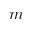<formula> <loc_0><loc_0><loc_500><loc_500>m</formula> 